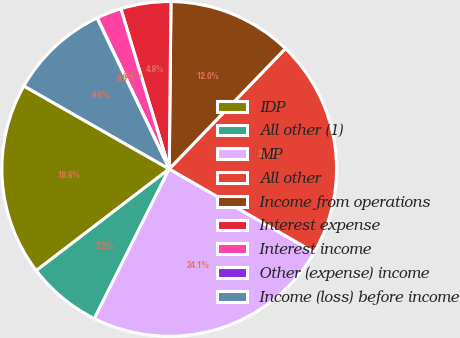<chart> <loc_0><loc_0><loc_500><loc_500><pie_chart><fcel>IDP<fcel>All other (1)<fcel>MP<fcel>All other<fcel>Income from operations<fcel>Interest expense<fcel>Interest income<fcel>Other (expense) income<fcel>Income (loss) before income<nl><fcel>18.65%<fcel>7.23%<fcel>24.08%<fcel>21.09%<fcel>12.05%<fcel>4.83%<fcel>2.42%<fcel>0.02%<fcel>9.64%<nl></chart> 